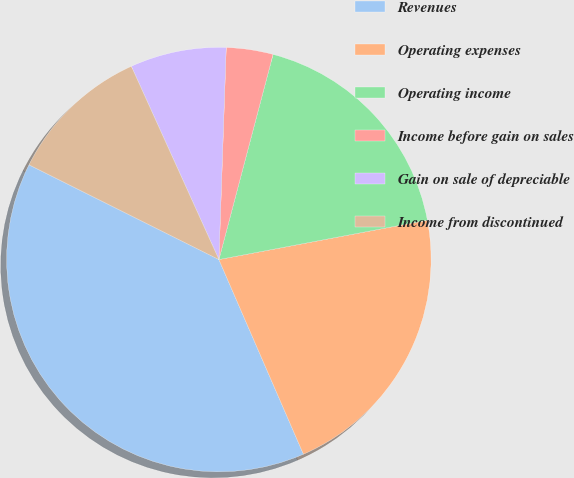<chart> <loc_0><loc_0><loc_500><loc_500><pie_chart><fcel>Revenues<fcel>Operating expenses<fcel>Operating income<fcel>Income before gain on sales<fcel>Gain on sale of depreciable<fcel>Income from discontinued<nl><fcel>38.89%<fcel>21.45%<fcel>17.92%<fcel>3.56%<fcel>7.32%<fcel>10.86%<nl></chart> 